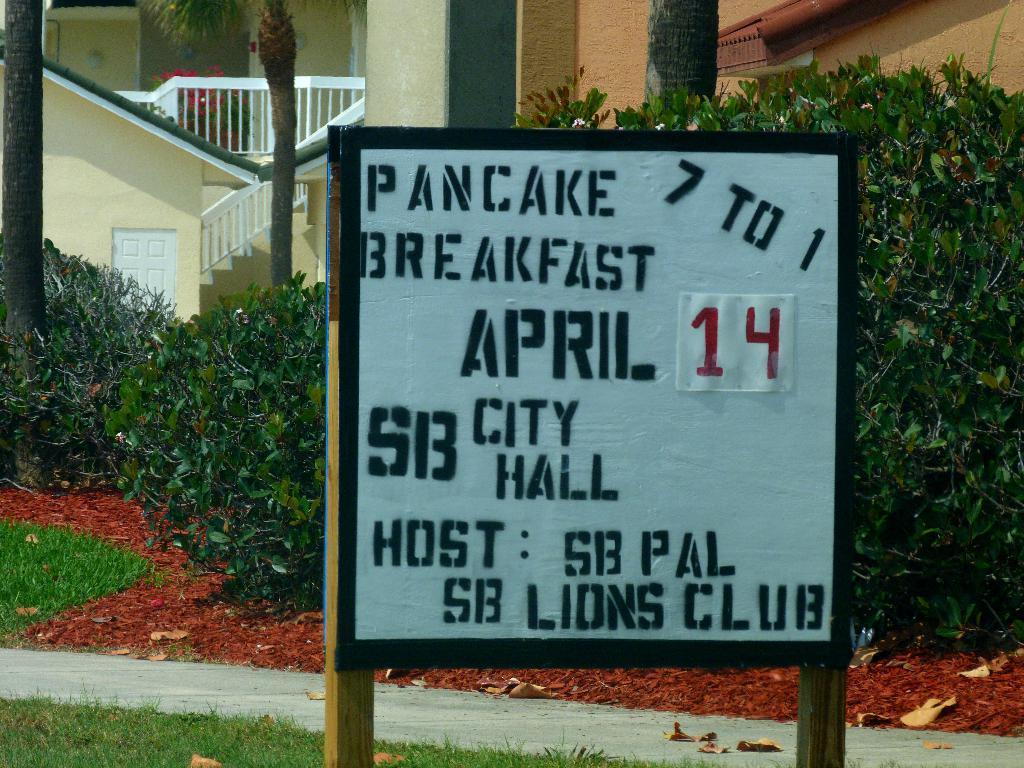In one or two sentences, can you explain what this image depicts? There is a board with wooden poles. On the board something is written. Near to that there is a road. On the ground there is grass. In the back there are trees. Also there is a building with railing and door. 